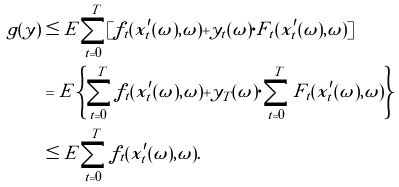<formula> <loc_0><loc_0><loc_500><loc_500>\tilde { g } ( y ) & \leq E \sum _ { t = 0 } ^ { T } [ f _ { t } ( x ^ { \prime } _ { t } ( \omega ) , \omega ) + y _ { t } ( \omega ) \cdot F _ { t } ( x ^ { \prime } _ { t } ( \omega ) , \omega ) ] \\ & = E \left \{ \sum _ { t = 0 } ^ { T } f _ { t } ( x ^ { \prime } _ { t } ( \omega ) , \omega ) + y _ { T } ( \omega ) \cdot \sum _ { t = 0 } ^ { T } F _ { t } ( x ^ { \prime } _ { t } ( \omega ) , \omega ) \right \} \\ & \leq E \sum _ { t = 0 } ^ { T } f _ { t } ( x ^ { \prime } _ { t } ( \omega ) , \omega ) .</formula> 